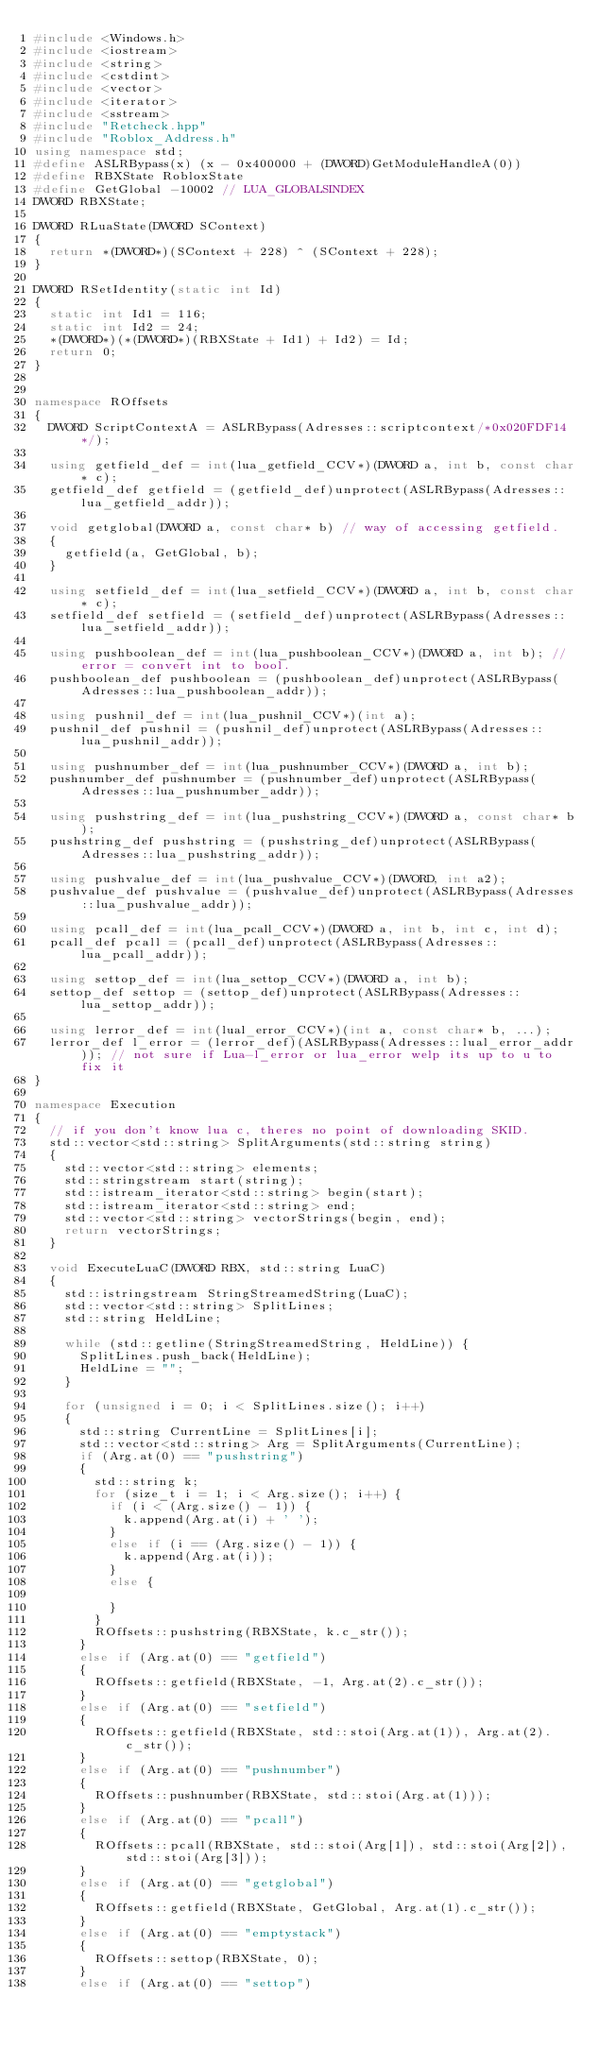<code> <loc_0><loc_0><loc_500><loc_500><_C++_>#include <Windows.h>
#include <iostream>
#include <string>
#include <cstdint>
#include <vector>
#include <iterator>
#include <sstream>
#include "Retcheck.hpp"
#include "Roblox_Address.h"
using namespace std;
#define ASLRBypass(x) (x - 0x400000 + (DWORD)GetModuleHandleA(0))
#define RBXState RobloxState
#define GetGlobal -10002 // LUA_GLOBALSINDEX
DWORD RBXState;

DWORD RLuaState(DWORD SContext)
{
	return *(DWORD*)(SContext + 228) ^ (SContext + 228);
}

DWORD RSetIdentity(static int Id)
{
	static int Id1 = 116;
	static int Id2 = 24;
	*(DWORD*)(*(DWORD*)(RBXState + Id1) + Id2) = Id;
	return 0;
}


namespace ROffsets
{
	DWORD ScriptContextA = ASLRBypass(Adresses::scriptcontext/*0x020FDF14*/);

	using getfield_def = int(lua_getfield_CCV*)(DWORD a, int b, const char* c);
	getfield_def getfield = (getfield_def)unprotect(ASLRBypass(Adresses::lua_getfield_addr));

	void getglobal(DWORD a, const char* b) // way of accessing getfield.
	{
		getfield(a, GetGlobal, b);
	}

	using setfield_def = int(lua_setfield_CCV*)(DWORD a, int b, const char* c);
	setfield_def setfield = (setfield_def)unprotect(ASLRBypass(Adresses::lua_setfield_addr));

	using pushboolean_def = int(lua_pushboolean_CCV*)(DWORD a, int b); // error = convert int to bool.
	pushboolean_def pushboolean = (pushboolean_def)unprotect(ASLRBypass(Adresses::lua_pushboolean_addr));

	using pushnil_def = int(lua_pushnil_CCV*)(int a);
	pushnil_def pushnil = (pushnil_def)unprotect(ASLRBypass(Adresses::lua_pushnil_addr));

	using pushnumber_def = int(lua_pushnumber_CCV*)(DWORD a, int b);
	pushnumber_def pushnumber = (pushnumber_def)unprotect(ASLRBypass(Adresses::lua_pushnumber_addr));

	using pushstring_def = int(lua_pushstring_CCV*)(DWORD a, const char* b);
	pushstring_def pushstring = (pushstring_def)unprotect(ASLRBypass(Adresses::lua_pushstring_addr));

	using pushvalue_def = int(lua_pushvalue_CCV*)(DWORD, int a2);
	pushvalue_def pushvalue = (pushvalue_def)unprotect(ASLRBypass(Adresses::lua_pushvalue_addr));

	using pcall_def = int(lua_pcall_CCV*)(DWORD a, int b, int c, int d);
	pcall_def pcall = (pcall_def)unprotect(ASLRBypass(Adresses::lua_pcall_addr));

	using settop_def = int(lua_settop_CCV*)(DWORD a, int b);
	settop_def settop = (settop_def)unprotect(ASLRBypass(Adresses::lua_settop_addr));

	using lerror_def = int(lual_error_CCV*)(int a, const char* b, ...);
	lerror_def l_error = (lerror_def)(ASLRBypass(Adresses::lual_error_addr)); // not sure if Lua-l_error or lua_error welp its up to u to fix it
}

namespace Execution
{
	// if you don't know lua c, theres no point of downloading SKID.
	std::vector<std::string> SplitArguments(std::string string)
	{
		std::vector<std::string> elements;
		std::stringstream start(string);
		std::istream_iterator<std::string> begin(start);
		std::istream_iterator<std::string> end;
		std::vector<std::string> vectorStrings(begin, end);
		return vectorStrings;
	}

	void ExecuteLuaC(DWORD RBX, std::string LuaC)
	{
		std::istringstream StringStreamedString(LuaC);
		std::vector<std::string> SplitLines;
		std::string HeldLine;

		while (std::getline(StringStreamedString, HeldLine)) {
			SplitLines.push_back(HeldLine);
			HeldLine = "";
		}

		for (unsigned i = 0; i < SplitLines.size(); i++)
		{
			std::string CurrentLine = SplitLines[i];
			std::vector<std::string> Arg = SplitArguments(CurrentLine);
			if (Arg.at(0) == "pushstring")
			{
				std::string k;
				for (size_t i = 1; i < Arg.size(); i++) {
					if (i < (Arg.size() - 1)) {
						k.append(Arg.at(i) + ' ');
					}
					else if (i == (Arg.size() - 1)) {
						k.append(Arg.at(i));
					}
					else {

					}
				}
				ROffsets::pushstring(RBXState, k.c_str());
			}
			else if (Arg.at(0) == "getfield")
			{
				ROffsets::getfield(RBXState, -1, Arg.at(2).c_str());
			}
			else if (Arg.at(0) == "setfield")
			{
				ROffsets::getfield(RBXState, std::stoi(Arg.at(1)), Arg.at(2).c_str());
			}
			else if (Arg.at(0) == "pushnumber")
			{
				ROffsets::pushnumber(RBXState, std::stoi(Arg.at(1)));
			}
			else if (Arg.at(0) == "pcall")
			{
				ROffsets::pcall(RBXState, std::stoi(Arg[1]), std::stoi(Arg[2]), std::stoi(Arg[3]));
			}
			else if (Arg.at(0) == "getglobal")
			{
				ROffsets::getfield(RBXState, GetGlobal, Arg.at(1).c_str());
			}
			else if (Arg.at(0) == "emptystack")
			{
				ROffsets::settop(RBXState, 0);
			}
			else if (Arg.at(0) == "settop")</code> 